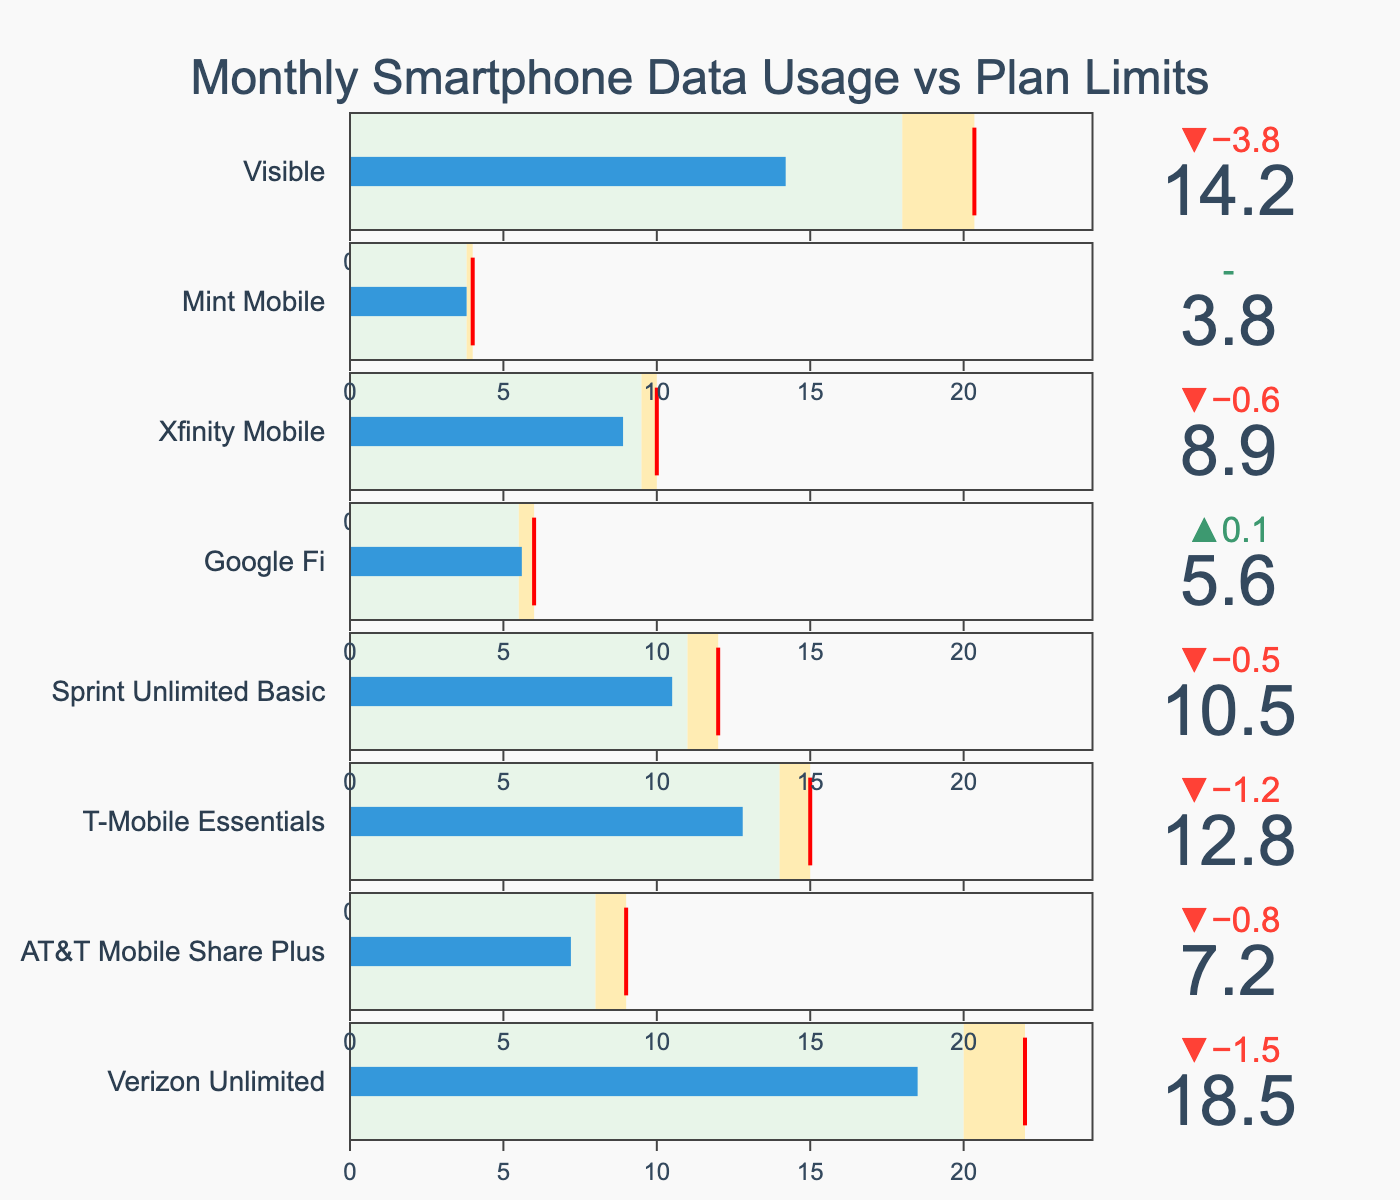What's the title of the figure? The title is typically at the top of the figure, summarizing what it's about. In this case, the title reads "Monthly Smartphone Data Usage vs Plan Limits."
Answer: Monthly Smartphone Data Usage vs Plan Limits How many different smartphone plans are shown in the figure? Each plan is listed in the figure. Counting these plans, there are eight: Verizon Unlimited, AT&T Mobile Share Plus, T-Mobile Essentials, Sprint Unlimited Basic, Google Fi, Xfinity Mobile, Mint Mobile, and Visible.
Answer: 8 Which plan has the highest actual data usage? By looking at the bullet charts, the plan with the highest bar representing actual usage is Verizon Unlimited.
Answer: Verizon Unlimited What's the actual data usage for Mint Mobile? Find the bullet chart section for Mint Mobile and look at the actual data usage value inside the bar. It shows 3.8 GB.
Answer: 3.8 GB Which plan is closest to reaching its warning threshold but hasn't exceeded it? Check each plan's actual usage against its warning threshold. Mint Mobile's actual data usage (3.8 GB) matches its warning threshold exactly, making it closest without exceeding it.
Answer: Mint Mobile How much more data can T-Mobile Essentials use before hitting its limit? T-Mobile Essentials has a limit of 15 GB and current usage is 12.8 GB. Subtract the actual usage from the limit: 15 GB - 12.8 GB = 2.2 GB.
Answer: 2.2 GB Which plan exceeded its warning threshold by the largest margin? Compare how much each plan's actual usage surpasses its warning threshold. Visible, with an actual usage of 14.2 GB and a warning threshold of 18 GB, does not exceed. The largest exceedance is 18.5 GB (Verizon Unlimited) over 20 GB (Warning), so 2.5 GB.
Answer: Verizon Unlimited What is the average limit of all the finite data plans? Sum the data limits for plans with finite limits and divide by the number of such plans. Limits are 22, 9, 15, 12, 6, 10, 4: (22 + 9 + 15 + 12 + 6 + 10 + 4) / 7 = 11.14 GB
Answer: 11.14 GB Which plan has the smallest buffer between its warning and limit thresholds? Calculate the difference between the warning and limit for each plan; the smallest positive difference indicates the smallest buffer. For Google Fi: 6 - 5.5 = 0.5 GB, which is the smallest.
Answer: Google Fi Are there any plans with unlimited data? Check the limit values in the chart to see if any mention "Unlimited." Visible has an unlimited data plan.
Answer: Visible 